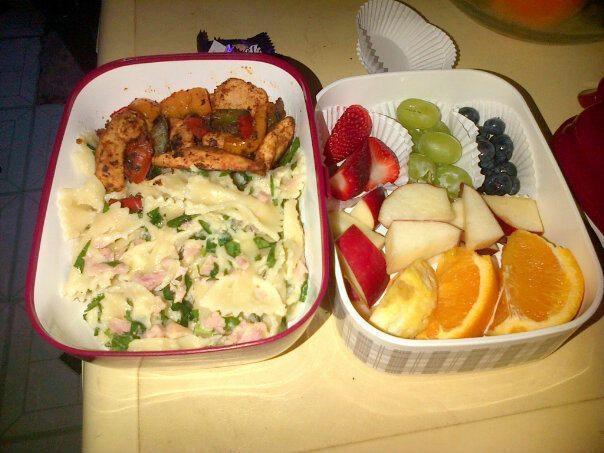How many bowls can be seen?
Give a very brief answer. 2. How many oranges are visible?
Give a very brief answer. 3. 